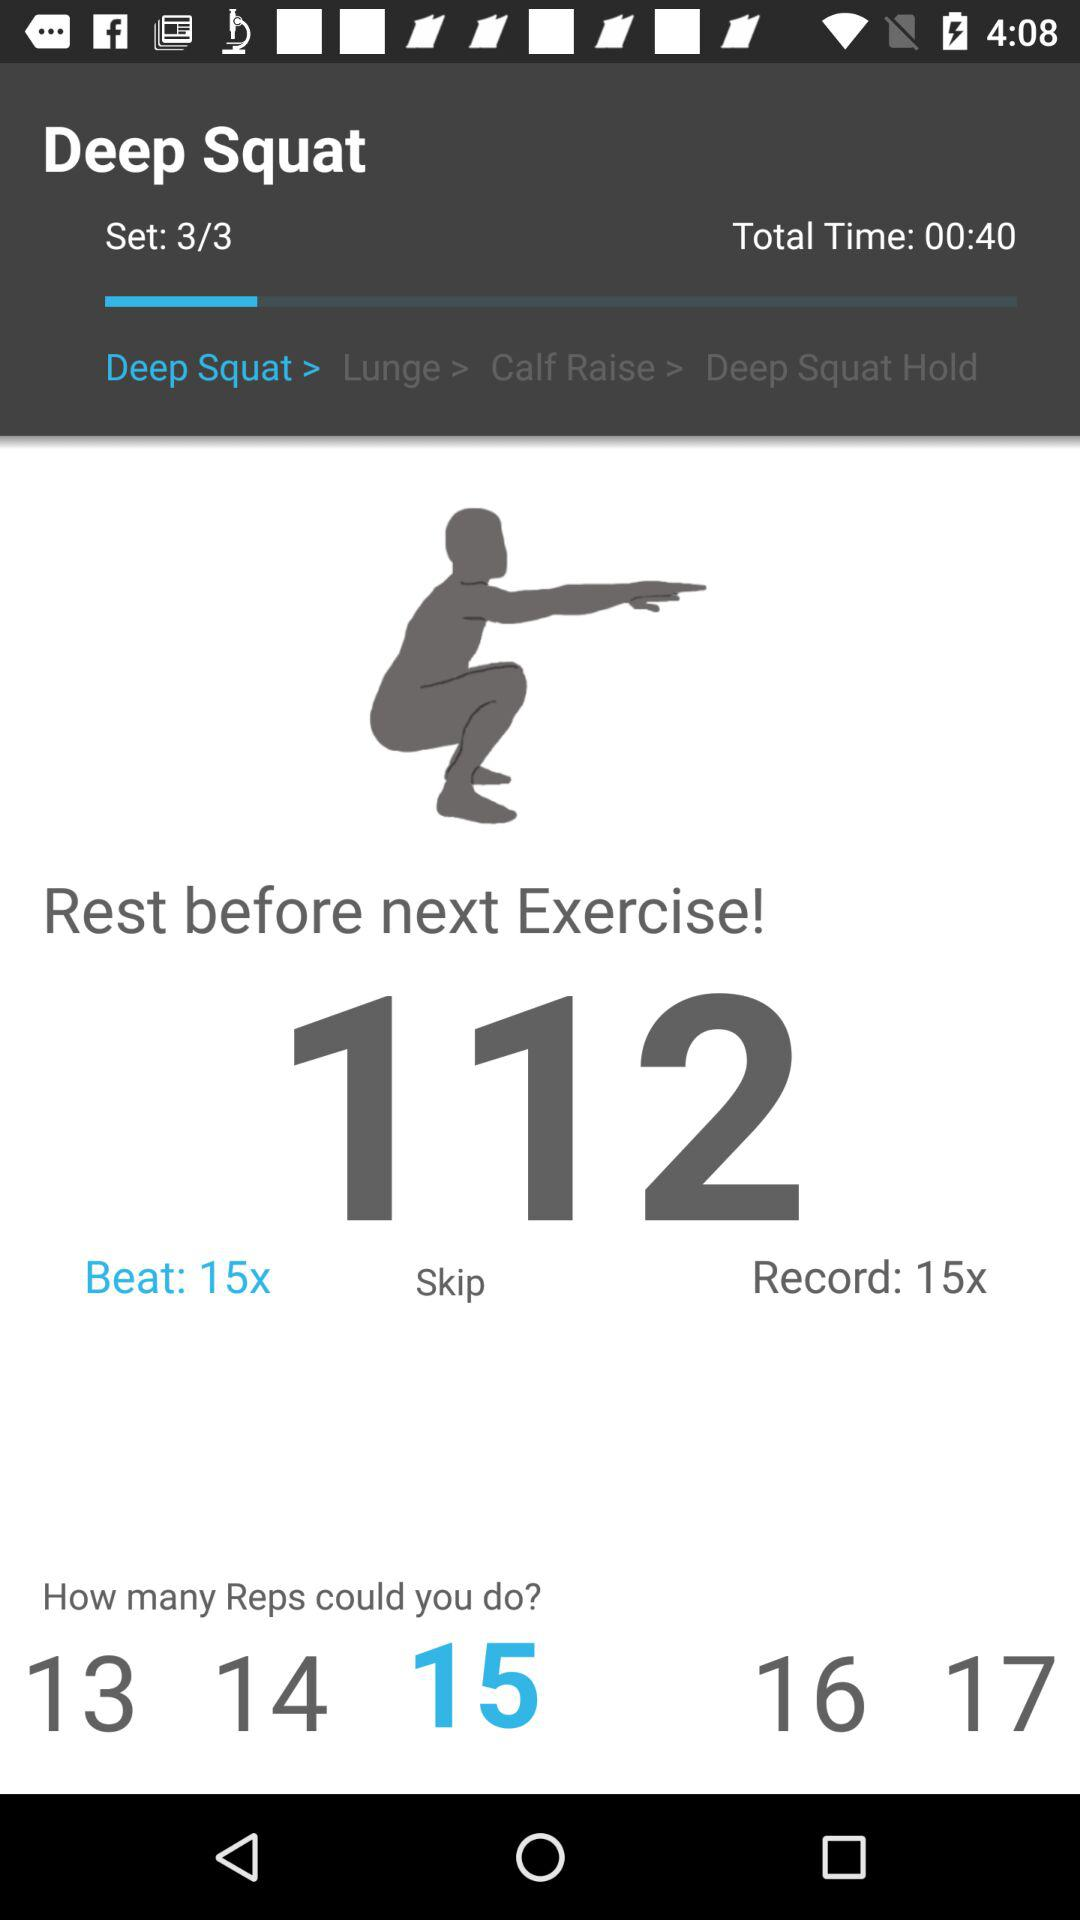What is the total time taken for the deep squat? The total time taken for the deep squat is 00:40. 